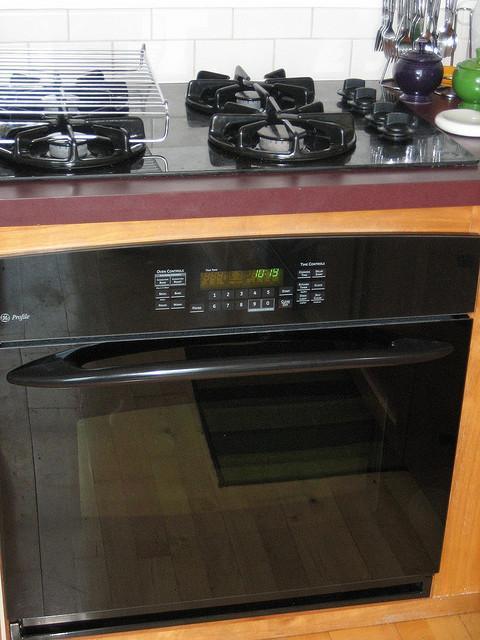How many elephants are there?
Give a very brief answer. 0. 